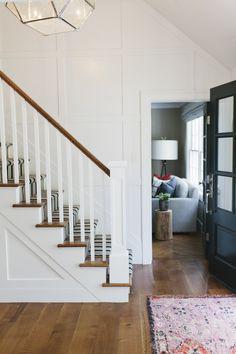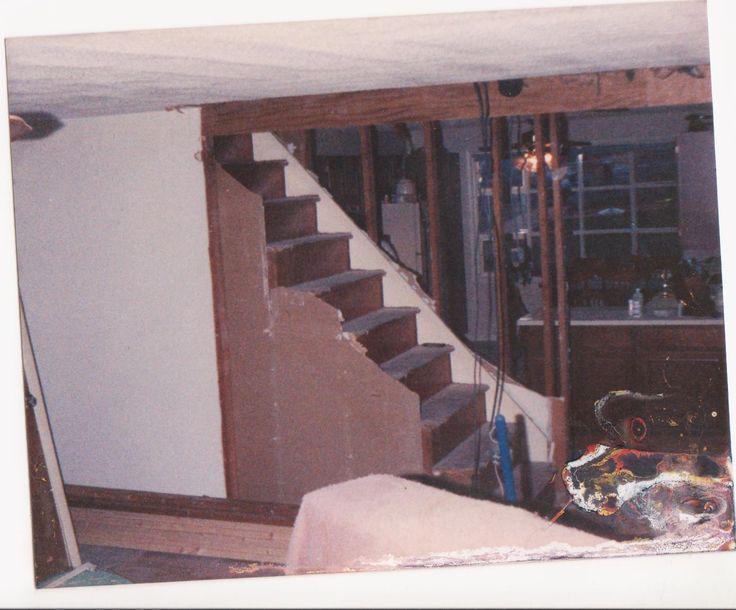The first image is the image on the left, the second image is the image on the right. Assess this claim about the two images: "One staircase has a white side edge and descends without turns midway, and the other staircase has zig-zag turns.". Correct or not? Answer yes or no. No. The first image is the image on the left, the second image is the image on the right. Evaluate the accuracy of this statement regarding the images: "All the stairs go in at least two directions.". Is it true? Answer yes or no. No. 